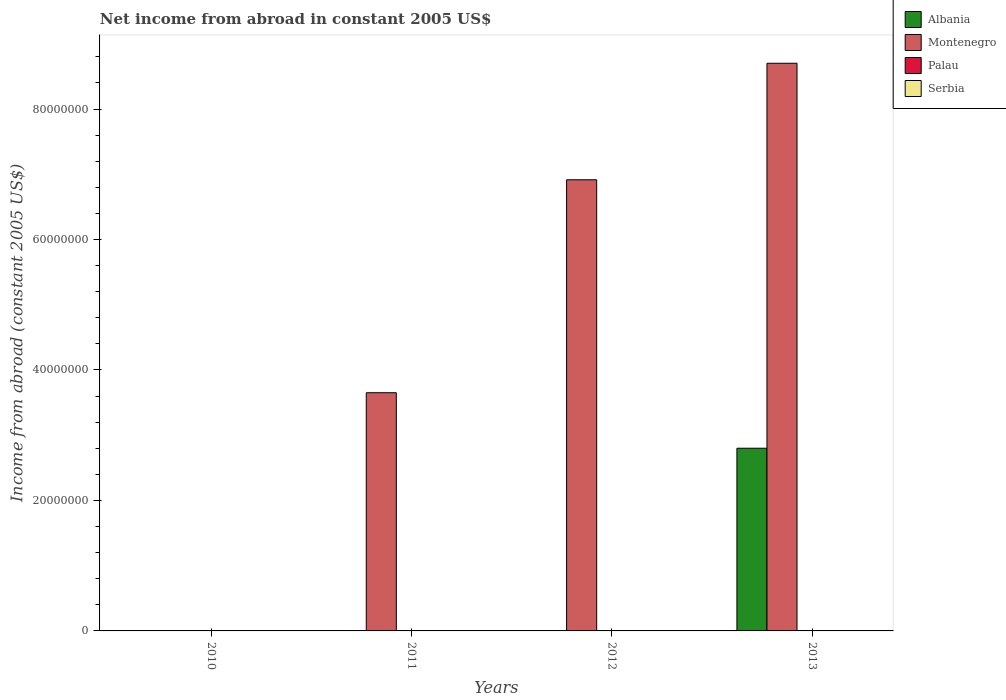Are the number of bars on each tick of the X-axis equal?
Make the answer very short. No. How many bars are there on the 4th tick from the left?
Ensure brevity in your answer.  2. What is the net income from abroad in Albania in 2011?
Offer a terse response. 0. Across all years, what is the maximum net income from abroad in Albania?
Give a very brief answer. 2.80e+07. In which year was the net income from abroad in Albania maximum?
Your answer should be very brief. 2013. What is the total net income from abroad in Palau in the graph?
Provide a succinct answer. 0. What is the difference between the net income from abroad in Montenegro in 2011 and that in 2013?
Make the answer very short. -5.05e+07. What is the average net income from abroad in Albania per year?
Offer a very short reply. 7.00e+06. What is the difference between the highest and the second highest net income from abroad in Montenegro?
Give a very brief answer. 1.79e+07. What is the difference between the highest and the lowest net income from abroad in Montenegro?
Make the answer very short. 8.70e+07. In how many years, is the net income from abroad in Serbia greater than the average net income from abroad in Serbia taken over all years?
Provide a short and direct response. 0. Is it the case that in every year, the sum of the net income from abroad in Serbia and net income from abroad in Palau is greater than the net income from abroad in Albania?
Ensure brevity in your answer.  No. What is the difference between two consecutive major ticks on the Y-axis?
Your answer should be very brief. 2.00e+07. How many legend labels are there?
Offer a very short reply. 4. What is the title of the graph?
Your response must be concise. Net income from abroad in constant 2005 US$. Does "Fiji" appear as one of the legend labels in the graph?
Provide a short and direct response. No. What is the label or title of the X-axis?
Your answer should be very brief. Years. What is the label or title of the Y-axis?
Offer a very short reply. Income from abroad (constant 2005 US$). What is the Income from abroad (constant 2005 US$) in Montenegro in 2010?
Provide a short and direct response. 0. What is the Income from abroad (constant 2005 US$) in Palau in 2010?
Provide a short and direct response. 0. What is the Income from abroad (constant 2005 US$) of Serbia in 2010?
Your answer should be compact. 0. What is the Income from abroad (constant 2005 US$) of Albania in 2011?
Your answer should be compact. 0. What is the Income from abroad (constant 2005 US$) of Montenegro in 2011?
Offer a terse response. 3.65e+07. What is the Income from abroad (constant 2005 US$) of Serbia in 2011?
Your response must be concise. 0. What is the Income from abroad (constant 2005 US$) in Albania in 2012?
Offer a very short reply. 0. What is the Income from abroad (constant 2005 US$) in Montenegro in 2012?
Provide a succinct answer. 6.92e+07. What is the Income from abroad (constant 2005 US$) in Palau in 2012?
Your answer should be very brief. 0. What is the Income from abroad (constant 2005 US$) of Albania in 2013?
Your answer should be compact. 2.80e+07. What is the Income from abroad (constant 2005 US$) of Montenegro in 2013?
Your answer should be compact. 8.70e+07. What is the Income from abroad (constant 2005 US$) in Palau in 2013?
Offer a terse response. 0. What is the Income from abroad (constant 2005 US$) in Serbia in 2013?
Provide a short and direct response. 0. Across all years, what is the maximum Income from abroad (constant 2005 US$) in Albania?
Offer a very short reply. 2.80e+07. Across all years, what is the maximum Income from abroad (constant 2005 US$) of Montenegro?
Provide a succinct answer. 8.70e+07. What is the total Income from abroad (constant 2005 US$) of Albania in the graph?
Ensure brevity in your answer.  2.80e+07. What is the total Income from abroad (constant 2005 US$) in Montenegro in the graph?
Offer a very short reply. 1.93e+08. What is the total Income from abroad (constant 2005 US$) in Palau in the graph?
Offer a very short reply. 0. What is the difference between the Income from abroad (constant 2005 US$) of Montenegro in 2011 and that in 2012?
Ensure brevity in your answer.  -3.26e+07. What is the difference between the Income from abroad (constant 2005 US$) in Montenegro in 2011 and that in 2013?
Ensure brevity in your answer.  -5.05e+07. What is the difference between the Income from abroad (constant 2005 US$) of Montenegro in 2012 and that in 2013?
Your answer should be compact. -1.79e+07. What is the average Income from abroad (constant 2005 US$) in Albania per year?
Your answer should be very brief. 7.00e+06. What is the average Income from abroad (constant 2005 US$) of Montenegro per year?
Provide a short and direct response. 4.82e+07. What is the average Income from abroad (constant 2005 US$) in Serbia per year?
Offer a very short reply. 0. In the year 2013, what is the difference between the Income from abroad (constant 2005 US$) in Albania and Income from abroad (constant 2005 US$) in Montenegro?
Offer a terse response. -5.90e+07. What is the ratio of the Income from abroad (constant 2005 US$) of Montenegro in 2011 to that in 2012?
Offer a terse response. 0.53. What is the ratio of the Income from abroad (constant 2005 US$) in Montenegro in 2011 to that in 2013?
Ensure brevity in your answer.  0.42. What is the ratio of the Income from abroad (constant 2005 US$) of Montenegro in 2012 to that in 2013?
Offer a very short reply. 0.79. What is the difference between the highest and the second highest Income from abroad (constant 2005 US$) of Montenegro?
Keep it short and to the point. 1.79e+07. What is the difference between the highest and the lowest Income from abroad (constant 2005 US$) of Albania?
Provide a short and direct response. 2.80e+07. What is the difference between the highest and the lowest Income from abroad (constant 2005 US$) in Montenegro?
Offer a terse response. 8.70e+07. 